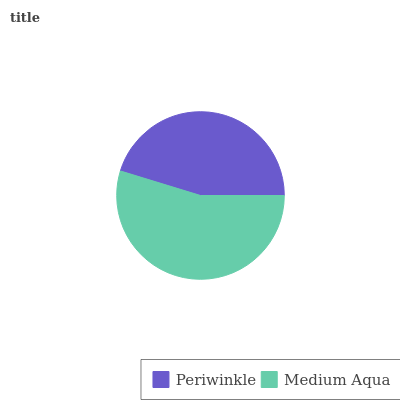Is Periwinkle the minimum?
Answer yes or no. Yes. Is Medium Aqua the maximum?
Answer yes or no. Yes. Is Medium Aqua the minimum?
Answer yes or no. No. Is Medium Aqua greater than Periwinkle?
Answer yes or no. Yes. Is Periwinkle less than Medium Aqua?
Answer yes or no. Yes. Is Periwinkle greater than Medium Aqua?
Answer yes or no. No. Is Medium Aqua less than Periwinkle?
Answer yes or no. No. Is Medium Aqua the high median?
Answer yes or no. Yes. Is Periwinkle the low median?
Answer yes or no. Yes. Is Periwinkle the high median?
Answer yes or no. No. Is Medium Aqua the low median?
Answer yes or no. No. 